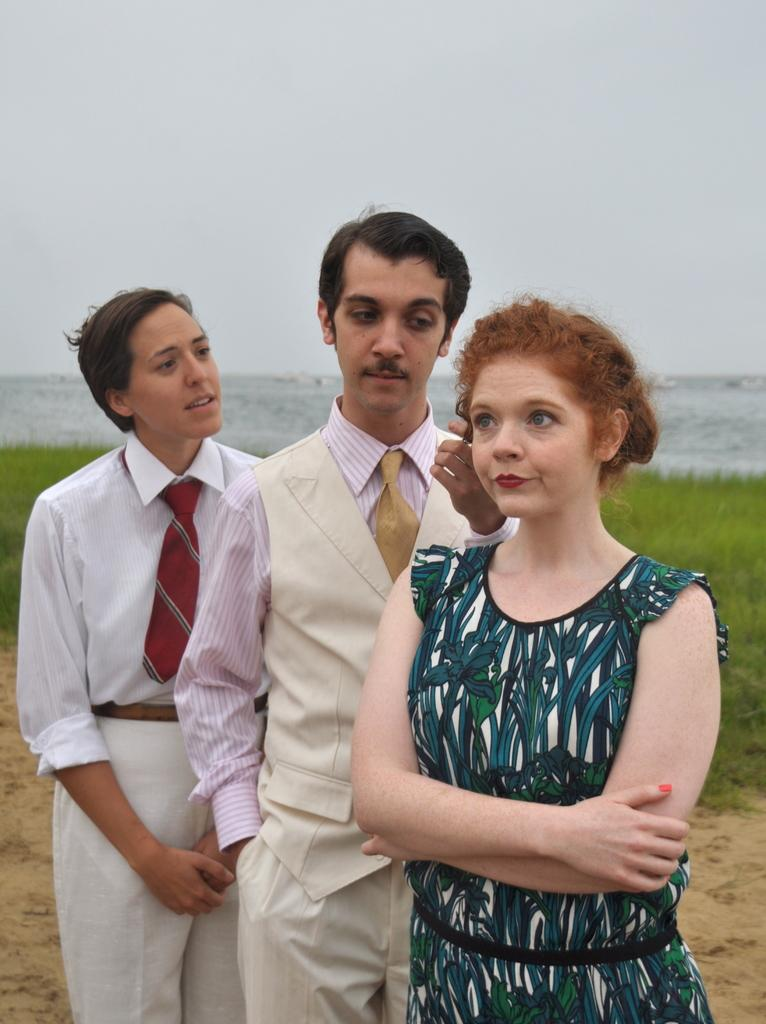How many people are in the image? There are three people in the image. What are the people doing in the image? The people are standing. What type of environment is visible in the background of the image? There is grass and water visible in the background of the image. What type of smoke can be seen coming from the people in the image? There is no smoke present in the image; the people are simply standing. 